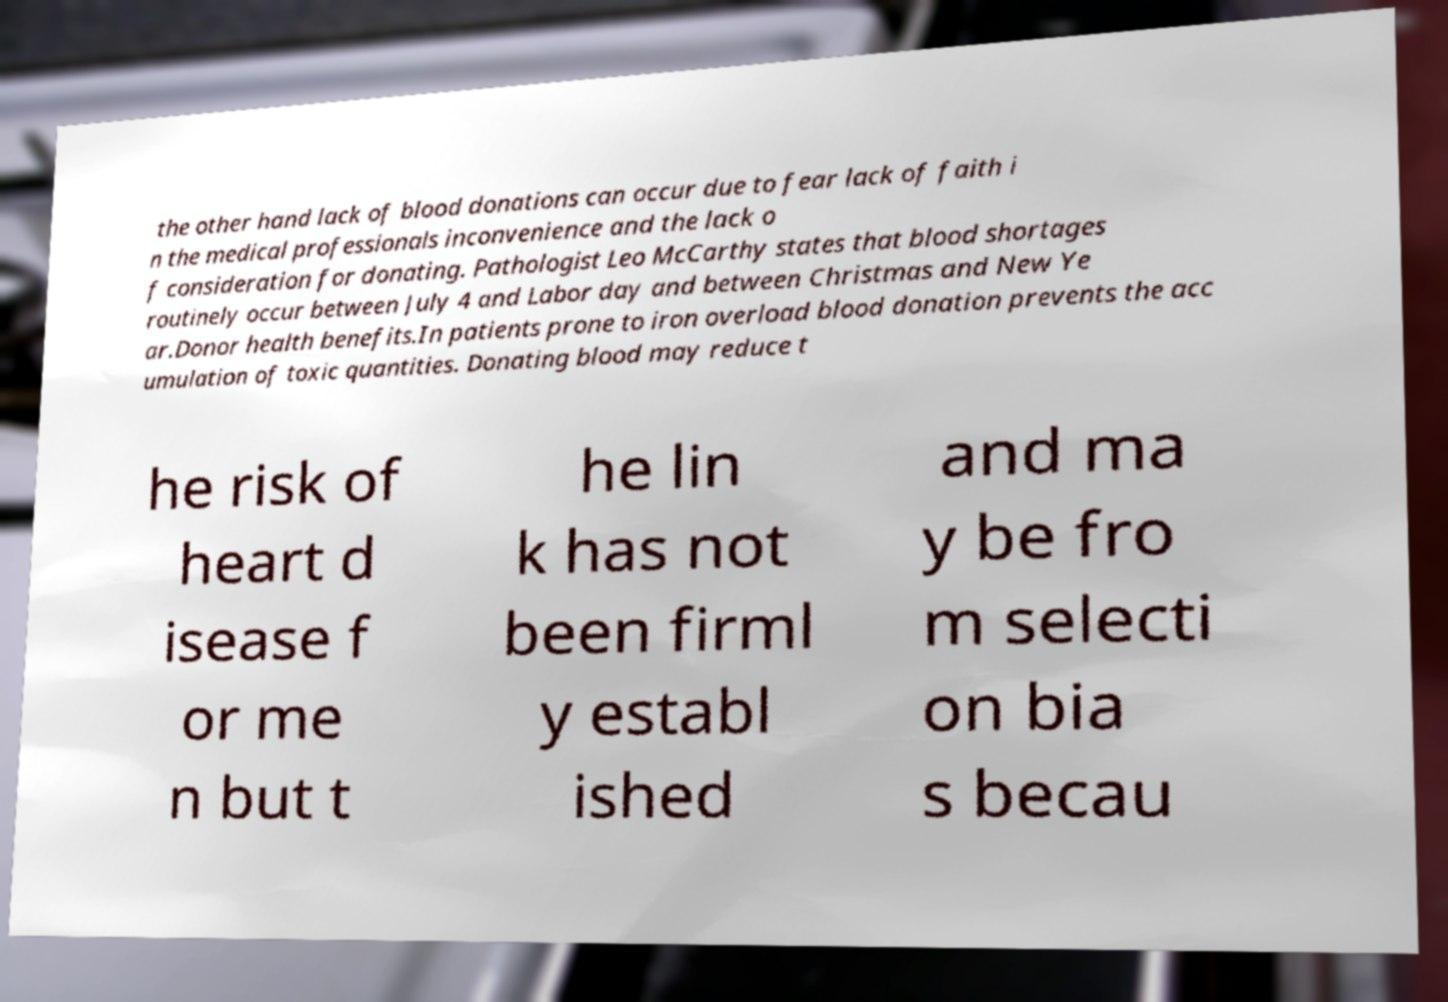Could you assist in decoding the text presented in this image and type it out clearly? the other hand lack of blood donations can occur due to fear lack of faith i n the medical professionals inconvenience and the lack o f consideration for donating. Pathologist Leo McCarthy states that blood shortages routinely occur between July 4 and Labor day and between Christmas and New Ye ar.Donor health benefits.In patients prone to iron overload blood donation prevents the acc umulation of toxic quantities. Donating blood may reduce t he risk of heart d isease f or me n but t he lin k has not been firml y establ ished and ma y be fro m selecti on bia s becau 